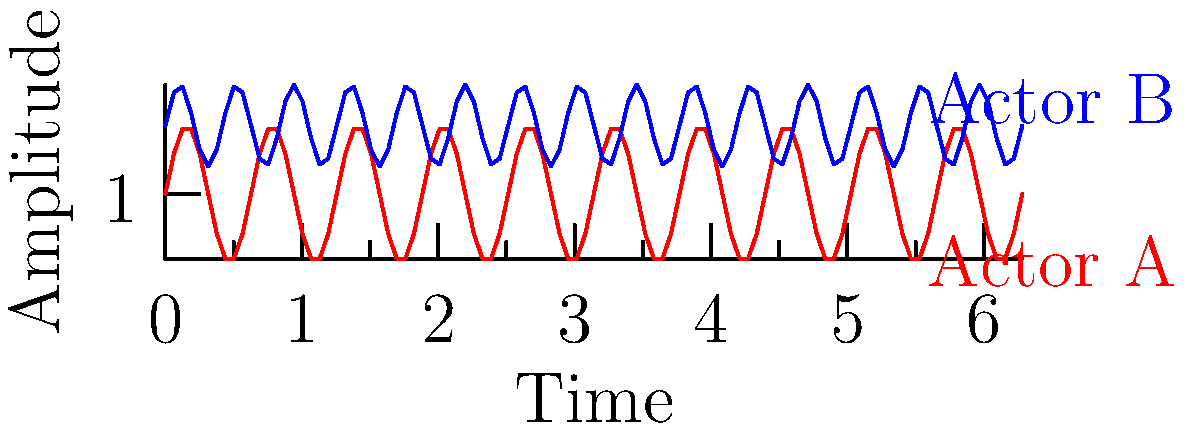Based on the sound wave visualizations of two actors' vocal performances, which actor would you recommend for a role requiring a wider vocal range and stronger projection? To determine which actor has a wider vocal range and stronger projection, we need to analyze the sound wave visualizations:

1. Amplitude:
   - Actor A's wave oscillates between approximately 0.5 and 1.5 units.
   - Actor B's wave oscillates between approximately 1.2 and 1.8 units.
   - The amplitude of a sound wave represents loudness or projection.

2. Frequency:
   - Actor A's wave completes about 3 cycles in the given time frame.
   - Actor B's wave completes about 4.5 cycles in the same time frame.
   - Higher frequency indicates a higher pitch.

3. Range:
   - Actor A's wave has a larger amplitude range (1 unit) compared to Actor B (0.6 units).
   - This suggests Actor A has a wider vocal range.

4. Projection:
   - Although Actor B's wave is generally higher on the amplitude scale, Actor A's wave shows more significant variations in amplitude.
   - Larger amplitude variations often indicate better control and stronger projection.

Considering these factors, Actor A demonstrates a wider vocal range (larger amplitude range) and potentially stronger projection (more significant amplitude variations). While Actor B shows consistency in a higher amplitude range, Actor A's performance suggests more versatility and dynamic control.
Answer: Actor A 